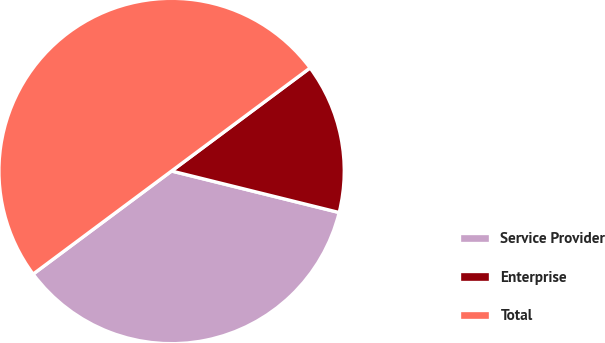Convert chart to OTSL. <chart><loc_0><loc_0><loc_500><loc_500><pie_chart><fcel>Service Provider<fcel>Enterprise<fcel>Total<nl><fcel>35.95%<fcel>14.05%<fcel>50.0%<nl></chart> 